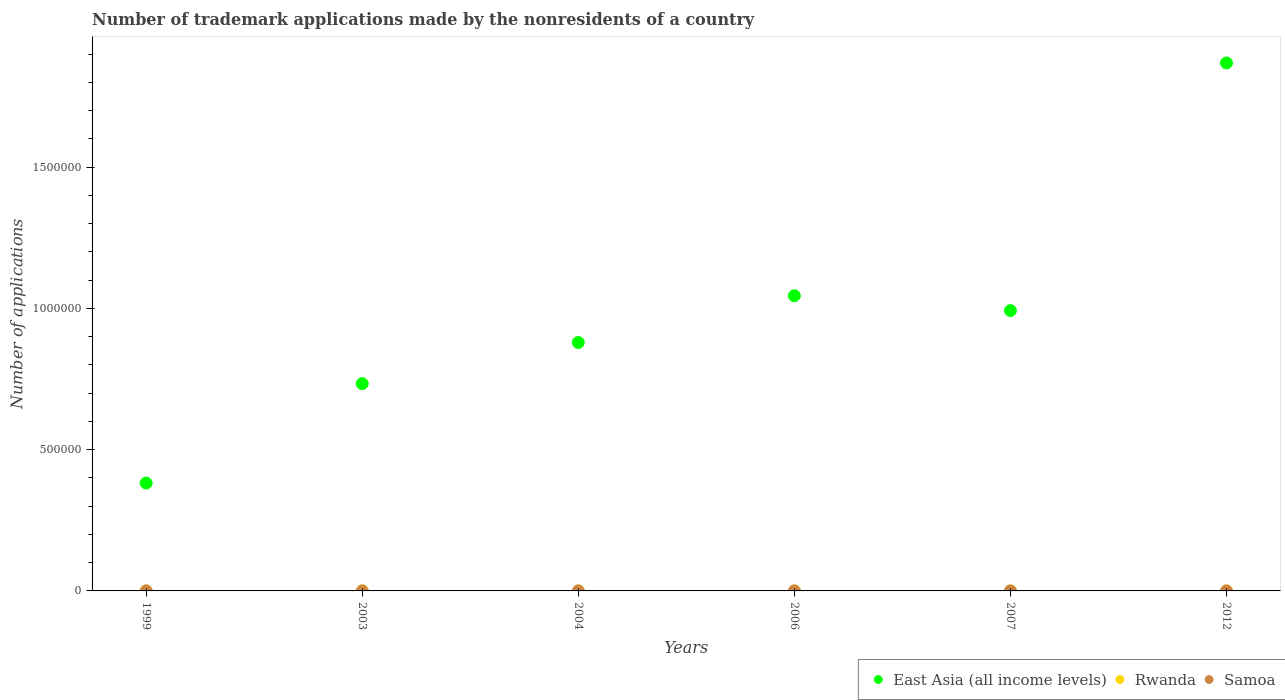Is the number of dotlines equal to the number of legend labels?
Provide a short and direct response. Yes. What is the number of trademark applications made by the nonresidents in Samoa in 2012?
Your answer should be very brief. 23. Across all years, what is the minimum number of trademark applications made by the nonresidents in Samoa?
Provide a succinct answer. 8. In which year was the number of trademark applications made by the nonresidents in Samoa maximum?
Offer a very short reply. 2006. In which year was the number of trademark applications made by the nonresidents in Rwanda minimum?
Offer a terse response. 1999. What is the total number of trademark applications made by the nonresidents in East Asia (all income levels) in the graph?
Give a very brief answer. 5.90e+06. What is the difference between the number of trademark applications made by the nonresidents in Samoa in 2003 and that in 2006?
Your response must be concise. -53. What is the difference between the number of trademark applications made by the nonresidents in Samoa in 2003 and the number of trademark applications made by the nonresidents in Rwanda in 2012?
Keep it short and to the point. -98. What is the average number of trademark applications made by the nonresidents in Samoa per year?
Offer a terse response. 24.33. In the year 2007, what is the difference between the number of trademark applications made by the nonresidents in East Asia (all income levels) and number of trademark applications made by the nonresidents in Rwanda?
Your response must be concise. 9.92e+05. What is the difference between the highest and the lowest number of trademark applications made by the nonresidents in Rwanda?
Offer a terse response. 174. In how many years, is the number of trademark applications made by the nonresidents in East Asia (all income levels) greater than the average number of trademark applications made by the nonresidents in East Asia (all income levels) taken over all years?
Provide a succinct answer. 3. Is the sum of the number of trademark applications made by the nonresidents in Samoa in 2003 and 2006 greater than the maximum number of trademark applications made by the nonresidents in Rwanda across all years?
Your answer should be compact. No. Is the number of trademark applications made by the nonresidents in Rwanda strictly greater than the number of trademark applications made by the nonresidents in East Asia (all income levels) over the years?
Your response must be concise. No. What is the difference between two consecutive major ticks on the Y-axis?
Make the answer very short. 5.00e+05. Does the graph contain grids?
Offer a very short reply. No. What is the title of the graph?
Your answer should be very brief. Number of trademark applications made by the nonresidents of a country. What is the label or title of the X-axis?
Provide a short and direct response. Years. What is the label or title of the Y-axis?
Your answer should be very brief. Number of applications. What is the Number of applications of East Asia (all income levels) in 1999?
Give a very brief answer. 3.82e+05. What is the Number of applications in Rwanda in 1999?
Make the answer very short. 5. What is the Number of applications of Samoa in 1999?
Make the answer very short. 8. What is the Number of applications in East Asia (all income levels) in 2003?
Keep it short and to the point. 7.34e+05. What is the Number of applications of Rwanda in 2003?
Make the answer very short. 179. What is the Number of applications in East Asia (all income levels) in 2004?
Offer a very short reply. 8.80e+05. What is the Number of applications in Samoa in 2004?
Keep it short and to the point. 11. What is the Number of applications in East Asia (all income levels) in 2006?
Offer a very short reply. 1.05e+06. What is the Number of applications of Rwanda in 2006?
Make the answer very short. 26. What is the Number of applications of East Asia (all income levels) in 2007?
Ensure brevity in your answer.  9.93e+05. What is the Number of applications in Rwanda in 2007?
Provide a short and direct response. 14. What is the Number of applications of Samoa in 2007?
Offer a very short reply. 29. What is the Number of applications in East Asia (all income levels) in 2012?
Offer a very short reply. 1.87e+06. What is the Number of applications of Rwanda in 2012?
Provide a succinct answer. 109. What is the Number of applications of Samoa in 2012?
Offer a terse response. 23. Across all years, what is the maximum Number of applications in East Asia (all income levels)?
Your answer should be compact. 1.87e+06. Across all years, what is the maximum Number of applications in Rwanda?
Make the answer very short. 179. Across all years, what is the minimum Number of applications of East Asia (all income levels)?
Provide a short and direct response. 3.82e+05. Across all years, what is the minimum Number of applications in Rwanda?
Your answer should be compact. 5. What is the total Number of applications in East Asia (all income levels) in the graph?
Keep it short and to the point. 5.90e+06. What is the total Number of applications of Rwanda in the graph?
Offer a very short reply. 373. What is the total Number of applications of Samoa in the graph?
Your response must be concise. 146. What is the difference between the Number of applications in East Asia (all income levels) in 1999 and that in 2003?
Give a very brief answer. -3.52e+05. What is the difference between the Number of applications in Rwanda in 1999 and that in 2003?
Your answer should be compact. -174. What is the difference between the Number of applications in Samoa in 1999 and that in 2003?
Provide a succinct answer. -3. What is the difference between the Number of applications in East Asia (all income levels) in 1999 and that in 2004?
Offer a terse response. -4.98e+05. What is the difference between the Number of applications in Rwanda in 1999 and that in 2004?
Provide a short and direct response. -35. What is the difference between the Number of applications in Samoa in 1999 and that in 2004?
Your answer should be compact. -3. What is the difference between the Number of applications of East Asia (all income levels) in 1999 and that in 2006?
Offer a very short reply. -6.63e+05. What is the difference between the Number of applications of Samoa in 1999 and that in 2006?
Ensure brevity in your answer.  -56. What is the difference between the Number of applications of East Asia (all income levels) in 1999 and that in 2007?
Give a very brief answer. -6.11e+05. What is the difference between the Number of applications of East Asia (all income levels) in 1999 and that in 2012?
Your answer should be very brief. -1.49e+06. What is the difference between the Number of applications in Rwanda in 1999 and that in 2012?
Keep it short and to the point. -104. What is the difference between the Number of applications of Samoa in 1999 and that in 2012?
Ensure brevity in your answer.  -15. What is the difference between the Number of applications of East Asia (all income levels) in 2003 and that in 2004?
Your answer should be compact. -1.46e+05. What is the difference between the Number of applications in Rwanda in 2003 and that in 2004?
Ensure brevity in your answer.  139. What is the difference between the Number of applications in Samoa in 2003 and that in 2004?
Make the answer very short. 0. What is the difference between the Number of applications in East Asia (all income levels) in 2003 and that in 2006?
Your answer should be compact. -3.11e+05. What is the difference between the Number of applications of Rwanda in 2003 and that in 2006?
Make the answer very short. 153. What is the difference between the Number of applications in Samoa in 2003 and that in 2006?
Offer a very short reply. -53. What is the difference between the Number of applications in East Asia (all income levels) in 2003 and that in 2007?
Provide a succinct answer. -2.59e+05. What is the difference between the Number of applications of Rwanda in 2003 and that in 2007?
Give a very brief answer. 165. What is the difference between the Number of applications of Samoa in 2003 and that in 2007?
Your response must be concise. -18. What is the difference between the Number of applications in East Asia (all income levels) in 2003 and that in 2012?
Your response must be concise. -1.14e+06. What is the difference between the Number of applications in East Asia (all income levels) in 2004 and that in 2006?
Your answer should be compact. -1.66e+05. What is the difference between the Number of applications of Rwanda in 2004 and that in 2006?
Your response must be concise. 14. What is the difference between the Number of applications in Samoa in 2004 and that in 2006?
Provide a succinct answer. -53. What is the difference between the Number of applications of East Asia (all income levels) in 2004 and that in 2007?
Keep it short and to the point. -1.13e+05. What is the difference between the Number of applications of Rwanda in 2004 and that in 2007?
Make the answer very short. 26. What is the difference between the Number of applications in East Asia (all income levels) in 2004 and that in 2012?
Provide a short and direct response. -9.90e+05. What is the difference between the Number of applications of Rwanda in 2004 and that in 2012?
Your answer should be very brief. -69. What is the difference between the Number of applications of Samoa in 2004 and that in 2012?
Keep it short and to the point. -12. What is the difference between the Number of applications in East Asia (all income levels) in 2006 and that in 2007?
Your response must be concise. 5.26e+04. What is the difference between the Number of applications of Samoa in 2006 and that in 2007?
Your answer should be compact. 35. What is the difference between the Number of applications of East Asia (all income levels) in 2006 and that in 2012?
Your answer should be very brief. -8.24e+05. What is the difference between the Number of applications of Rwanda in 2006 and that in 2012?
Your answer should be very brief. -83. What is the difference between the Number of applications in East Asia (all income levels) in 2007 and that in 2012?
Your answer should be very brief. -8.77e+05. What is the difference between the Number of applications of Rwanda in 2007 and that in 2012?
Make the answer very short. -95. What is the difference between the Number of applications of East Asia (all income levels) in 1999 and the Number of applications of Rwanda in 2003?
Give a very brief answer. 3.82e+05. What is the difference between the Number of applications of East Asia (all income levels) in 1999 and the Number of applications of Samoa in 2003?
Ensure brevity in your answer.  3.82e+05. What is the difference between the Number of applications of East Asia (all income levels) in 1999 and the Number of applications of Rwanda in 2004?
Keep it short and to the point. 3.82e+05. What is the difference between the Number of applications in East Asia (all income levels) in 1999 and the Number of applications in Samoa in 2004?
Make the answer very short. 3.82e+05. What is the difference between the Number of applications in East Asia (all income levels) in 1999 and the Number of applications in Rwanda in 2006?
Make the answer very short. 3.82e+05. What is the difference between the Number of applications of East Asia (all income levels) in 1999 and the Number of applications of Samoa in 2006?
Give a very brief answer. 3.82e+05. What is the difference between the Number of applications in Rwanda in 1999 and the Number of applications in Samoa in 2006?
Your answer should be compact. -59. What is the difference between the Number of applications of East Asia (all income levels) in 1999 and the Number of applications of Rwanda in 2007?
Make the answer very short. 3.82e+05. What is the difference between the Number of applications of East Asia (all income levels) in 1999 and the Number of applications of Samoa in 2007?
Provide a succinct answer. 3.82e+05. What is the difference between the Number of applications in Rwanda in 1999 and the Number of applications in Samoa in 2007?
Offer a very short reply. -24. What is the difference between the Number of applications of East Asia (all income levels) in 1999 and the Number of applications of Rwanda in 2012?
Your answer should be compact. 3.82e+05. What is the difference between the Number of applications of East Asia (all income levels) in 1999 and the Number of applications of Samoa in 2012?
Keep it short and to the point. 3.82e+05. What is the difference between the Number of applications of East Asia (all income levels) in 2003 and the Number of applications of Rwanda in 2004?
Ensure brevity in your answer.  7.34e+05. What is the difference between the Number of applications in East Asia (all income levels) in 2003 and the Number of applications in Samoa in 2004?
Provide a short and direct response. 7.34e+05. What is the difference between the Number of applications of Rwanda in 2003 and the Number of applications of Samoa in 2004?
Your response must be concise. 168. What is the difference between the Number of applications of East Asia (all income levels) in 2003 and the Number of applications of Rwanda in 2006?
Your answer should be very brief. 7.34e+05. What is the difference between the Number of applications in East Asia (all income levels) in 2003 and the Number of applications in Samoa in 2006?
Provide a succinct answer. 7.34e+05. What is the difference between the Number of applications in Rwanda in 2003 and the Number of applications in Samoa in 2006?
Offer a very short reply. 115. What is the difference between the Number of applications in East Asia (all income levels) in 2003 and the Number of applications in Rwanda in 2007?
Offer a very short reply. 7.34e+05. What is the difference between the Number of applications of East Asia (all income levels) in 2003 and the Number of applications of Samoa in 2007?
Provide a short and direct response. 7.34e+05. What is the difference between the Number of applications in Rwanda in 2003 and the Number of applications in Samoa in 2007?
Keep it short and to the point. 150. What is the difference between the Number of applications in East Asia (all income levels) in 2003 and the Number of applications in Rwanda in 2012?
Your answer should be compact. 7.34e+05. What is the difference between the Number of applications of East Asia (all income levels) in 2003 and the Number of applications of Samoa in 2012?
Your answer should be compact. 7.34e+05. What is the difference between the Number of applications in Rwanda in 2003 and the Number of applications in Samoa in 2012?
Your answer should be compact. 156. What is the difference between the Number of applications of East Asia (all income levels) in 2004 and the Number of applications of Rwanda in 2006?
Offer a very short reply. 8.80e+05. What is the difference between the Number of applications of East Asia (all income levels) in 2004 and the Number of applications of Samoa in 2006?
Ensure brevity in your answer.  8.79e+05. What is the difference between the Number of applications of East Asia (all income levels) in 2004 and the Number of applications of Rwanda in 2007?
Keep it short and to the point. 8.80e+05. What is the difference between the Number of applications of East Asia (all income levels) in 2004 and the Number of applications of Samoa in 2007?
Provide a short and direct response. 8.80e+05. What is the difference between the Number of applications of East Asia (all income levels) in 2004 and the Number of applications of Rwanda in 2012?
Keep it short and to the point. 8.79e+05. What is the difference between the Number of applications in East Asia (all income levels) in 2004 and the Number of applications in Samoa in 2012?
Provide a succinct answer. 8.80e+05. What is the difference between the Number of applications in East Asia (all income levels) in 2006 and the Number of applications in Rwanda in 2007?
Provide a short and direct response. 1.05e+06. What is the difference between the Number of applications of East Asia (all income levels) in 2006 and the Number of applications of Samoa in 2007?
Provide a short and direct response. 1.05e+06. What is the difference between the Number of applications in East Asia (all income levels) in 2006 and the Number of applications in Rwanda in 2012?
Keep it short and to the point. 1.05e+06. What is the difference between the Number of applications in East Asia (all income levels) in 2006 and the Number of applications in Samoa in 2012?
Your response must be concise. 1.05e+06. What is the difference between the Number of applications in Rwanda in 2006 and the Number of applications in Samoa in 2012?
Offer a terse response. 3. What is the difference between the Number of applications in East Asia (all income levels) in 2007 and the Number of applications in Rwanda in 2012?
Offer a terse response. 9.92e+05. What is the difference between the Number of applications in East Asia (all income levels) in 2007 and the Number of applications in Samoa in 2012?
Your response must be concise. 9.92e+05. What is the average Number of applications of East Asia (all income levels) per year?
Your response must be concise. 9.84e+05. What is the average Number of applications of Rwanda per year?
Offer a very short reply. 62.17. What is the average Number of applications in Samoa per year?
Ensure brevity in your answer.  24.33. In the year 1999, what is the difference between the Number of applications in East Asia (all income levels) and Number of applications in Rwanda?
Offer a very short reply. 3.82e+05. In the year 1999, what is the difference between the Number of applications of East Asia (all income levels) and Number of applications of Samoa?
Your response must be concise. 3.82e+05. In the year 2003, what is the difference between the Number of applications in East Asia (all income levels) and Number of applications in Rwanda?
Your answer should be very brief. 7.34e+05. In the year 2003, what is the difference between the Number of applications in East Asia (all income levels) and Number of applications in Samoa?
Your answer should be compact. 7.34e+05. In the year 2003, what is the difference between the Number of applications in Rwanda and Number of applications in Samoa?
Offer a very short reply. 168. In the year 2004, what is the difference between the Number of applications in East Asia (all income levels) and Number of applications in Rwanda?
Offer a very short reply. 8.80e+05. In the year 2004, what is the difference between the Number of applications of East Asia (all income levels) and Number of applications of Samoa?
Give a very brief answer. 8.80e+05. In the year 2004, what is the difference between the Number of applications of Rwanda and Number of applications of Samoa?
Ensure brevity in your answer.  29. In the year 2006, what is the difference between the Number of applications of East Asia (all income levels) and Number of applications of Rwanda?
Your response must be concise. 1.05e+06. In the year 2006, what is the difference between the Number of applications in East Asia (all income levels) and Number of applications in Samoa?
Make the answer very short. 1.05e+06. In the year 2006, what is the difference between the Number of applications in Rwanda and Number of applications in Samoa?
Your answer should be very brief. -38. In the year 2007, what is the difference between the Number of applications of East Asia (all income levels) and Number of applications of Rwanda?
Give a very brief answer. 9.92e+05. In the year 2007, what is the difference between the Number of applications in East Asia (all income levels) and Number of applications in Samoa?
Your answer should be compact. 9.92e+05. In the year 2007, what is the difference between the Number of applications in Rwanda and Number of applications in Samoa?
Offer a very short reply. -15. In the year 2012, what is the difference between the Number of applications in East Asia (all income levels) and Number of applications in Rwanda?
Keep it short and to the point. 1.87e+06. In the year 2012, what is the difference between the Number of applications of East Asia (all income levels) and Number of applications of Samoa?
Ensure brevity in your answer.  1.87e+06. What is the ratio of the Number of applications in East Asia (all income levels) in 1999 to that in 2003?
Offer a very short reply. 0.52. What is the ratio of the Number of applications of Rwanda in 1999 to that in 2003?
Make the answer very short. 0.03. What is the ratio of the Number of applications in Samoa in 1999 to that in 2003?
Your answer should be compact. 0.73. What is the ratio of the Number of applications in East Asia (all income levels) in 1999 to that in 2004?
Keep it short and to the point. 0.43. What is the ratio of the Number of applications of Rwanda in 1999 to that in 2004?
Ensure brevity in your answer.  0.12. What is the ratio of the Number of applications of Samoa in 1999 to that in 2004?
Give a very brief answer. 0.73. What is the ratio of the Number of applications in East Asia (all income levels) in 1999 to that in 2006?
Your answer should be very brief. 0.37. What is the ratio of the Number of applications of Rwanda in 1999 to that in 2006?
Offer a terse response. 0.19. What is the ratio of the Number of applications of East Asia (all income levels) in 1999 to that in 2007?
Keep it short and to the point. 0.38. What is the ratio of the Number of applications of Rwanda in 1999 to that in 2007?
Ensure brevity in your answer.  0.36. What is the ratio of the Number of applications in Samoa in 1999 to that in 2007?
Your answer should be very brief. 0.28. What is the ratio of the Number of applications in East Asia (all income levels) in 1999 to that in 2012?
Give a very brief answer. 0.2. What is the ratio of the Number of applications of Rwanda in 1999 to that in 2012?
Give a very brief answer. 0.05. What is the ratio of the Number of applications of Samoa in 1999 to that in 2012?
Provide a succinct answer. 0.35. What is the ratio of the Number of applications in East Asia (all income levels) in 2003 to that in 2004?
Your answer should be very brief. 0.83. What is the ratio of the Number of applications of Rwanda in 2003 to that in 2004?
Provide a short and direct response. 4.47. What is the ratio of the Number of applications of Samoa in 2003 to that in 2004?
Your response must be concise. 1. What is the ratio of the Number of applications of East Asia (all income levels) in 2003 to that in 2006?
Ensure brevity in your answer.  0.7. What is the ratio of the Number of applications in Rwanda in 2003 to that in 2006?
Ensure brevity in your answer.  6.88. What is the ratio of the Number of applications of Samoa in 2003 to that in 2006?
Give a very brief answer. 0.17. What is the ratio of the Number of applications in East Asia (all income levels) in 2003 to that in 2007?
Provide a succinct answer. 0.74. What is the ratio of the Number of applications of Rwanda in 2003 to that in 2007?
Provide a succinct answer. 12.79. What is the ratio of the Number of applications in Samoa in 2003 to that in 2007?
Ensure brevity in your answer.  0.38. What is the ratio of the Number of applications in East Asia (all income levels) in 2003 to that in 2012?
Make the answer very short. 0.39. What is the ratio of the Number of applications in Rwanda in 2003 to that in 2012?
Make the answer very short. 1.64. What is the ratio of the Number of applications of Samoa in 2003 to that in 2012?
Offer a terse response. 0.48. What is the ratio of the Number of applications in East Asia (all income levels) in 2004 to that in 2006?
Provide a short and direct response. 0.84. What is the ratio of the Number of applications in Rwanda in 2004 to that in 2006?
Provide a succinct answer. 1.54. What is the ratio of the Number of applications in Samoa in 2004 to that in 2006?
Ensure brevity in your answer.  0.17. What is the ratio of the Number of applications of East Asia (all income levels) in 2004 to that in 2007?
Your answer should be very brief. 0.89. What is the ratio of the Number of applications of Rwanda in 2004 to that in 2007?
Your response must be concise. 2.86. What is the ratio of the Number of applications in Samoa in 2004 to that in 2007?
Provide a succinct answer. 0.38. What is the ratio of the Number of applications of East Asia (all income levels) in 2004 to that in 2012?
Offer a very short reply. 0.47. What is the ratio of the Number of applications in Rwanda in 2004 to that in 2012?
Offer a terse response. 0.37. What is the ratio of the Number of applications in Samoa in 2004 to that in 2012?
Give a very brief answer. 0.48. What is the ratio of the Number of applications in East Asia (all income levels) in 2006 to that in 2007?
Ensure brevity in your answer.  1.05. What is the ratio of the Number of applications in Rwanda in 2006 to that in 2007?
Your answer should be very brief. 1.86. What is the ratio of the Number of applications in Samoa in 2006 to that in 2007?
Your answer should be compact. 2.21. What is the ratio of the Number of applications in East Asia (all income levels) in 2006 to that in 2012?
Provide a short and direct response. 0.56. What is the ratio of the Number of applications in Rwanda in 2006 to that in 2012?
Provide a succinct answer. 0.24. What is the ratio of the Number of applications in Samoa in 2006 to that in 2012?
Provide a succinct answer. 2.78. What is the ratio of the Number of applications in East Asia (all income levels) in 2007 to that in 2012?
Keep it short and to the point. 0.53. What is the ratio of the Number of applications of Rwanda in 2007 to that in 2012?
Offer a very short reply. 0.13. What is the ratio of the Number of applications of Samoa in 2007 to that in 2012?
Your answer should be compact. 1.26. What is the difference between the highest and the second highest Number of applications in East Asia (all income levels)?
Provide a short and direct response. 8.24e+05. What is the difference between the highest and the lowest Number of applications in East Asia (all income levels)?
Keep it short and to the point. 1.49e+06. What is the difference between the highest and the lowest Number of applications of Rwanda?
Your response must be concise. 174. What is the difference between the highest and the lowest Number of applications in Samoa?
Offer a terse response. 56. 